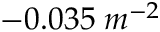Convert formula to latex. <formula><loc_0><loc_0><loc_500><loc_500>- 0 . 0 3 5 \, m ^ { - 2 }</formula> 